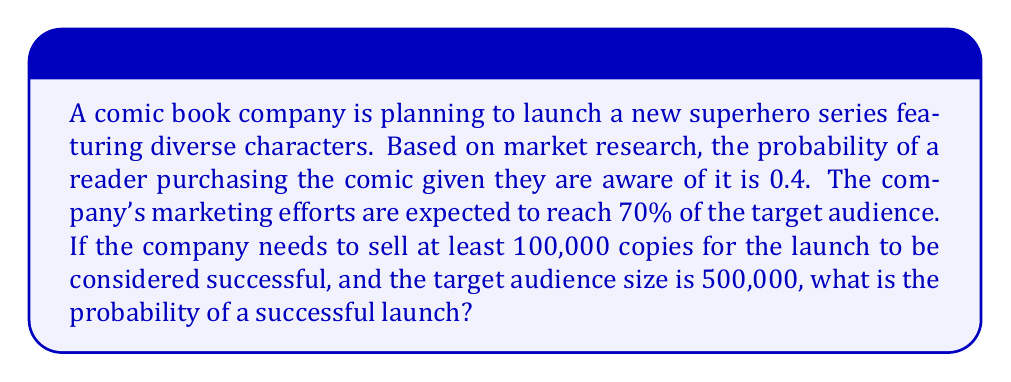Can you answer this question? Let's approach this step-by-step:

1) First, we need to calculate the number of people who are likely to be aware of the comic:
   $0.70 \times 500,000 = 350,000$ people

2) Now, we can calculate the probability of each aware person buying the comic:
   $p(\text{buy}) = 0.4$

3) The number of copies sold follows a binomial distribution. We can approximate this with a normal distribution since $n$ is large and $p$ is not too close to 0 or 1.

4) The mean of this distribution is:
   $\mu = np = 350,000 \times 0.4 = 140,000$

5) The standard deviation is:
   $\sigma = \sqrt{np(1-p)} = \sqrt{350,000 \times 0.4 \times 0.6} = \sqrt{84,000} \approx 289.83$

6) We want to find $P(X \geq 100,000)$, where $X$ is the number of copies sold.

7) We can standardize this to a z-score:
   $z = \frac{100,000 - 140,000}{289.83} \approx -138.01$

8) The probability of success is the area to the right of this z-score on a standard normal distribution:
   $P(Z > -138.01) \approx 1$

Therefore, the probability of selling at least 100,000 copies is essentially 1, or 100%.
Answer: $\approx 1$ or 100% 